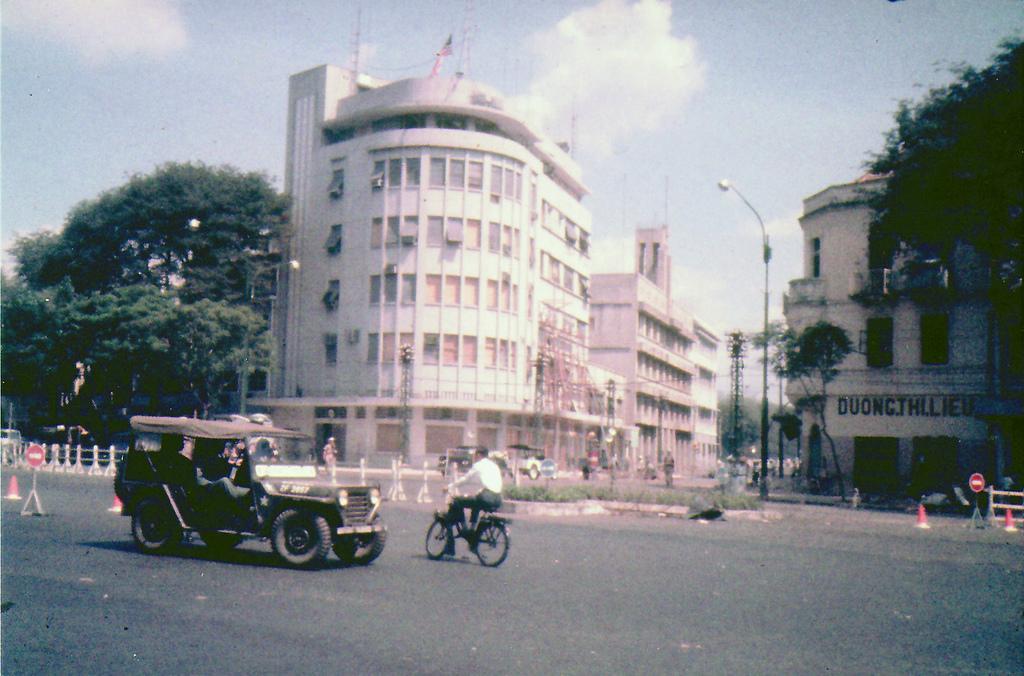Could you give a brief overview of what you see in this image? In this image, there are a few buildings, trees and people. We can see some vehicles. We can see the ground with some objects. We can see the fence and some sign boards. There are a few poles. We can see a tower and the sky with clouds. 